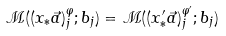Convert formula to latex. <formula><loc_0><loc_0><loc_500><loc_500>\mathcal { M } ( ( x _ { \ast } \vec { a } ) ^ { \varphi } _ { j } ; b _ { j } ) = \mathcal { M } ( ( x ^ { \prime } _ { \ast } \vec { a } ) ^ { \varphi ^ { \prime } } _ { j } ; b _ { j } )</formula> 